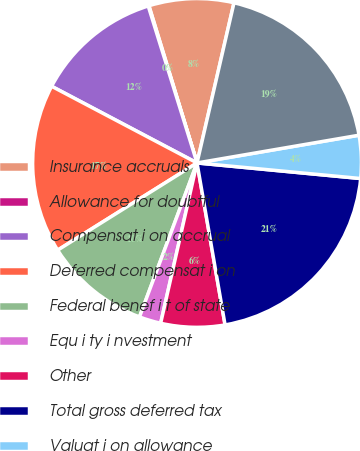Convert chart to OTSL. <chart><loc_0><loc_0><loc_500><loc_500><pie_chart><fcel>Insurance accruals<fcel>Allowance for doubtful<fcel>Compensat i on accrual<fcel>Deferred compensat i on<fcel>Federal benef i t of state<fcel>Equ i ty i nvestment<fcel>Other<fcel>Total gross deferred tax<fcel>Valuat i on allowance<fcel>Total deferred tax assets net<nl><fcel>8.34%<fcel>0.07%<fcel>12.48%<fcel>16.62%<fcel>10.41%<fcel>2.14%<fcel>6.28%<fcel>20.76%<fcel>4.21%<fcel>18.69%<nl></chart> 